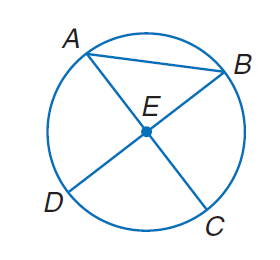Question: Suppose C E = 5.2 inches. Find the diameter of the circle.
Choices:
A. 2.6
B. 4.8
C. 10.4
D. 20.8
Answer with the letter. Answer: C Question: Suppose B D = 12 millimeters. Find the radius of the circle.
Choices:
A. 6
B. 12
C. 18
D. 36
Answer with the letter. Answer: A 